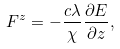<formula> <loc_0><loc_0><loc_500><loc_500>F ^ { z } = - \frac { c \lambda } { \chi } \frac { \partial E } { \partial z } ,</formula> 